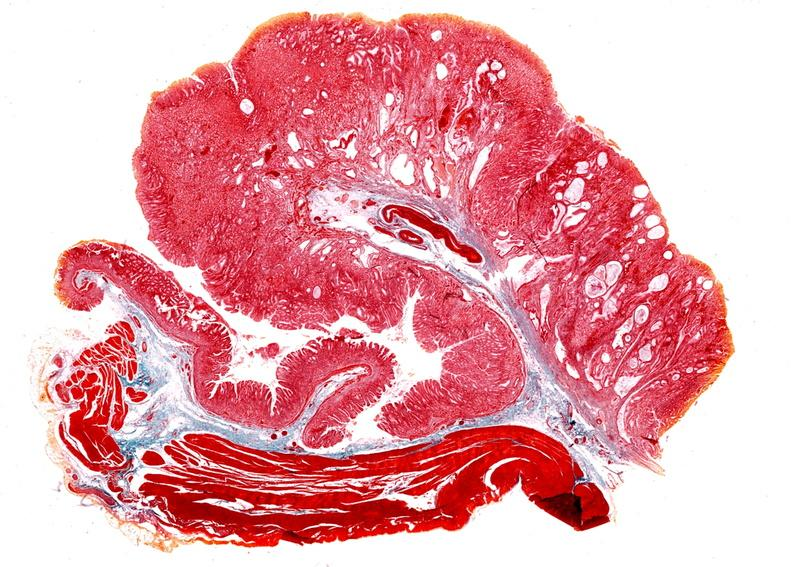s very good example present?
Answer the question using a single word or phrase. No 